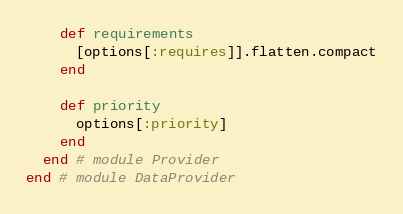<code> <loc_0><loc_0><loc_500><loc_500><_Ruby_>
    def requirements
      [options[:requires]].flatten.compact
    end

    def priority
      options[:priority]
    end
  end # module Provider
end # module DataProvider</code> 